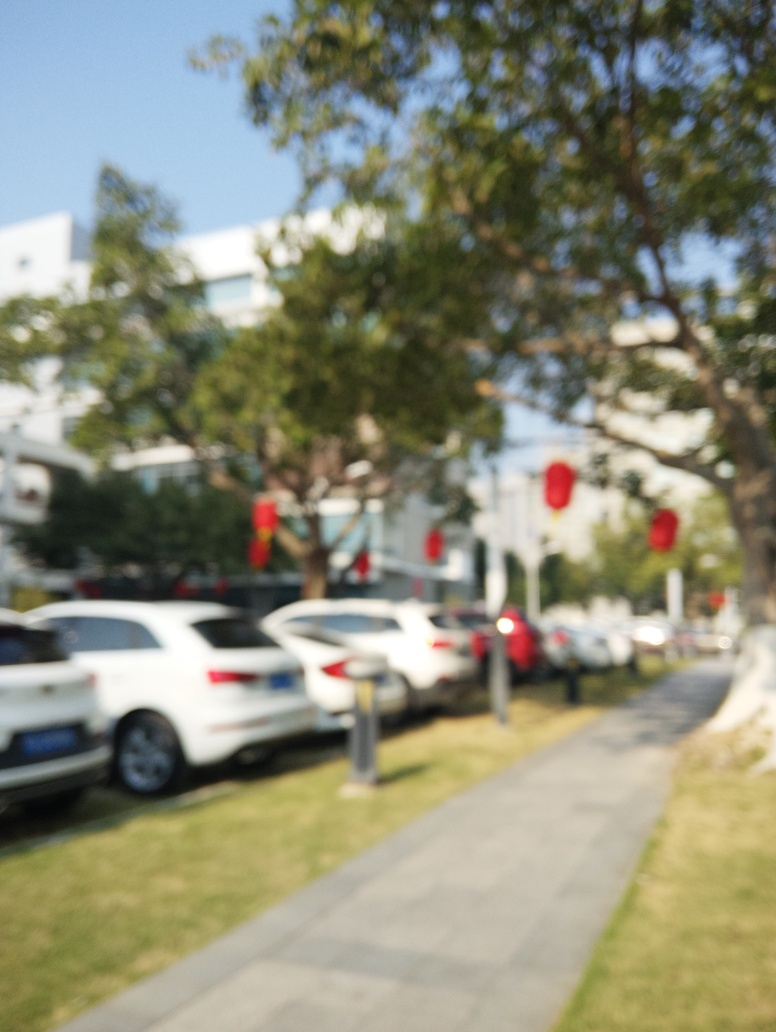Could the blur be intentional and what might it signify? The blur could potentially be an artistic choice, intending to convey a sense of motion, or evoke a dreamlike, ethereal quality. It might also signify the transient nature of moments or the imperfection of memory. 